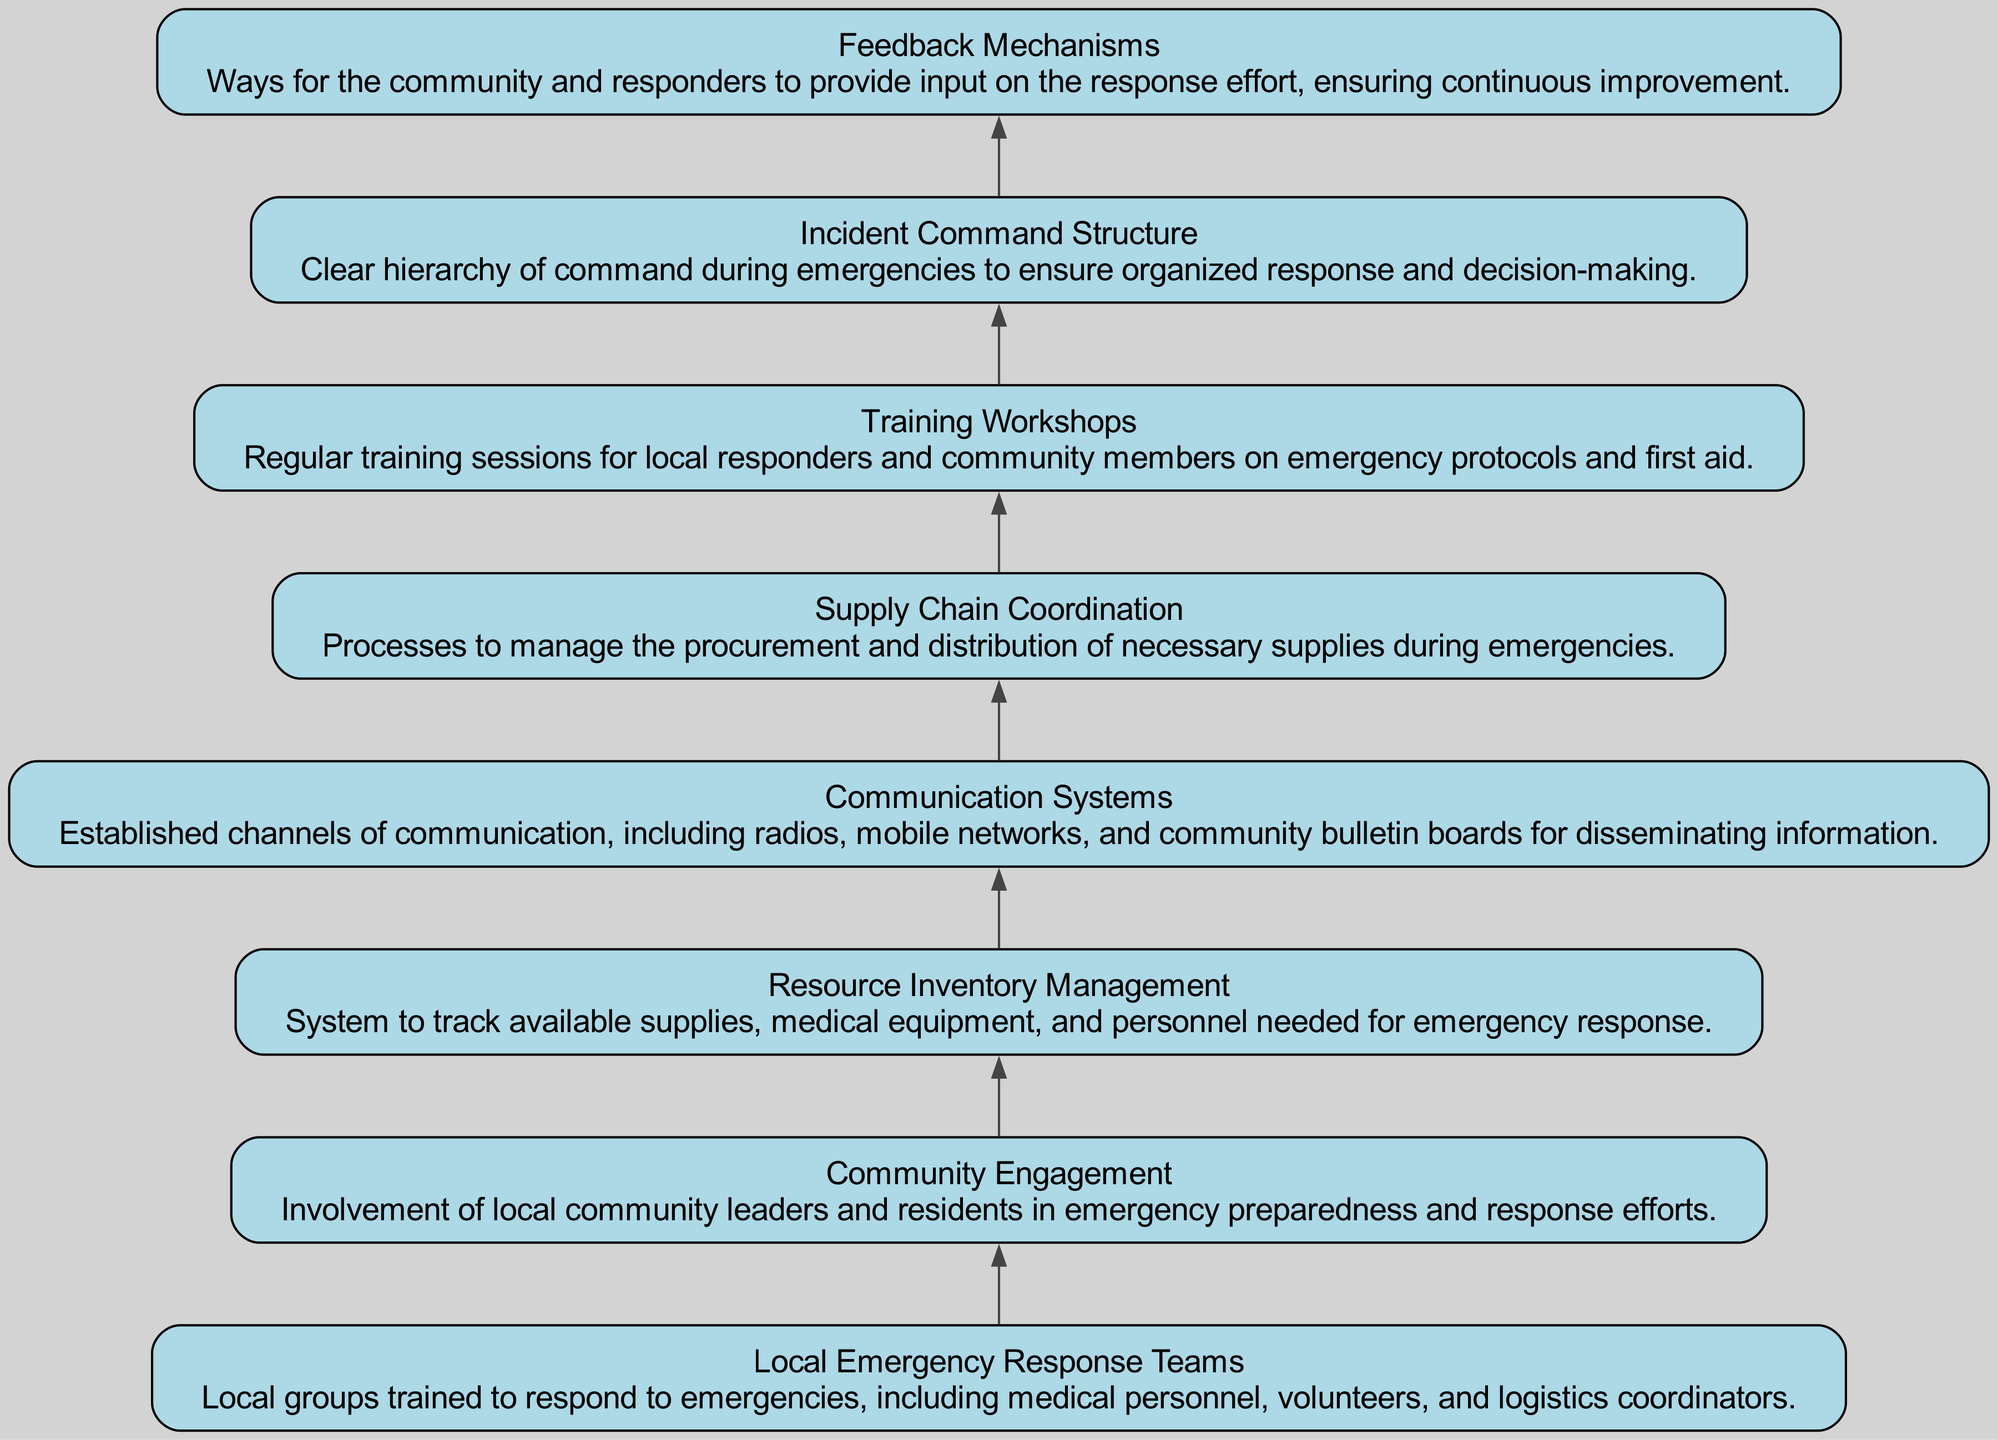What is the first element in the flowchart? The first element listed in the flowchart is "Local Emergency Response Teams," which is also the initial node of the diagram.
Answer: Local Emergency Response Teams How many total elements are in the diagram? By counting the nodes defined in the data, there are eight elements total, ranging from Local Emergency Response Teams to Feedback Mechanisms.
Answer: 8 Which element comes after "Communication Systems"? The diagram displays a sequential flow where "Supply Chain Coordination" directly follows "Communication Systems."
Answer: Supply Chain Coordination What is the purpose of the "Incident Command Structure"? The description indicates that it establishes a clear hierarchy for decision-making and response organization during emergencies.
Answer: Clear hierarchy of command Which two elements are linked directly in the flow? The flow directly connects "Resource Inventory Management" and "Communication Systems," showing a relationship between inventory management and how communication is carried out for emergencies.
Answer: Resource Inventory Management and Communication Systems How does "Community Engagement" influence the overall response plan? "Community Engagement" is vital as it ensures local leadership and residents are actively involved, which enhances preparedness and response effectiveness.
Answer: Enhances preparedness and response effectiveness What is the last element displayed in the flowchart? The final element in the sequential flow of the diagram is "Feedback Mechanisms," which provides a means for ongoing improvement and input from responders and the community.
Answer: Feedback Mechanisms Are "Training Workshops" and "Incident Command Structure" directly connected? In the diagram, no direct edge exists between "Training Workshops" and "Incident Command Structure," indicating they are part of the broader response plan but do not have a direct linking step.
Answer: No 